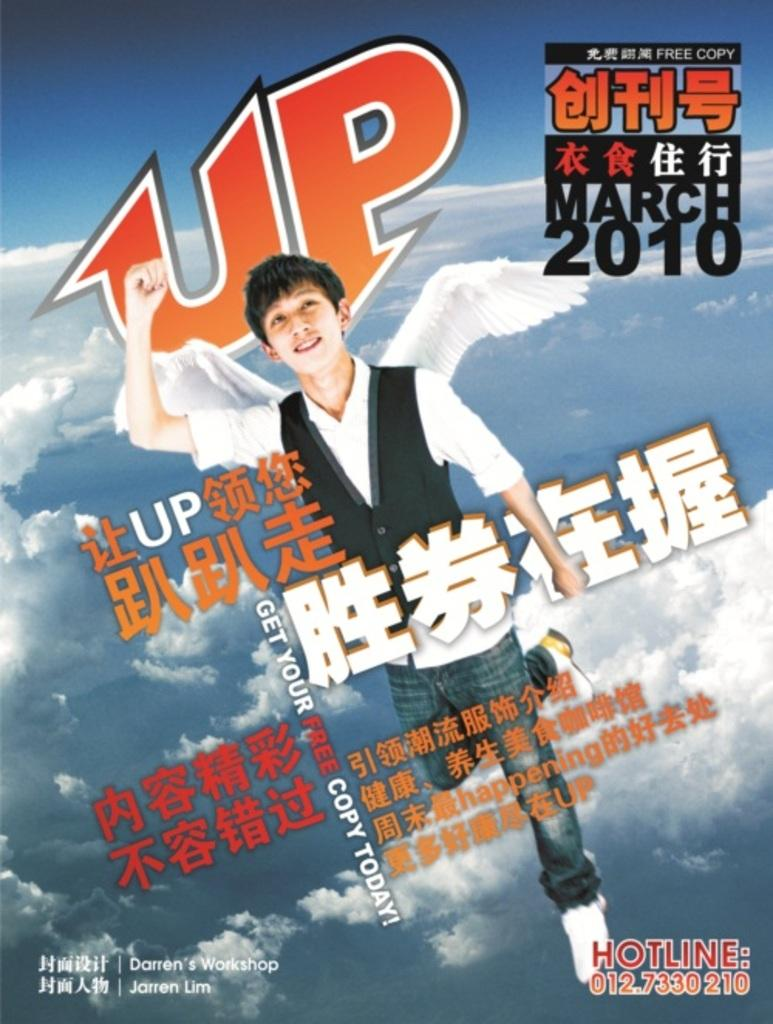What is the main subject of the image? The main subject of the image is a person with wings in the center of the image. What can be found in the foreground of the image? There is text in the foreground of the image. What is visible in the background of the image? There are clouds in the background of the image. What type of ink is used to write the text in the image? There is no information about the type of ink used in the image, as the focus is on the person with wings and the text itself. --- Facts: 1. There is a person sitting on a chair in the image. 2. The person is holding a book. 3. There is a table next to the chair. 4. There is a lamp on the table. 5. The background of the image is a room. Absurd Topics: elephant, ocean, bicycle Conversation: What is the person in the image doing? The person is sitting on a chair in the image. What is the person holding while sitting on the chair? The person is holding a book. What is located next to the chair in the image? There is a table next to the chair. What is on the table in the image? There is a lamp on the table. What is the setting of the image? The background of the image is a room. Reasoning: Let's think step by step in order to produce the conversation. We start by identifying the main subject of the image, which is the person sitting on the chair. Then, we describe the book the person is holding, the table and lamp next to the chair, and the room setting. We avoid yes/no questions and ensure that the language is simple and clear. Absurd Question/Answer: Can you see an elephant swimming in the ocean in the image? No, there is no elephant or ocean present in the image. 